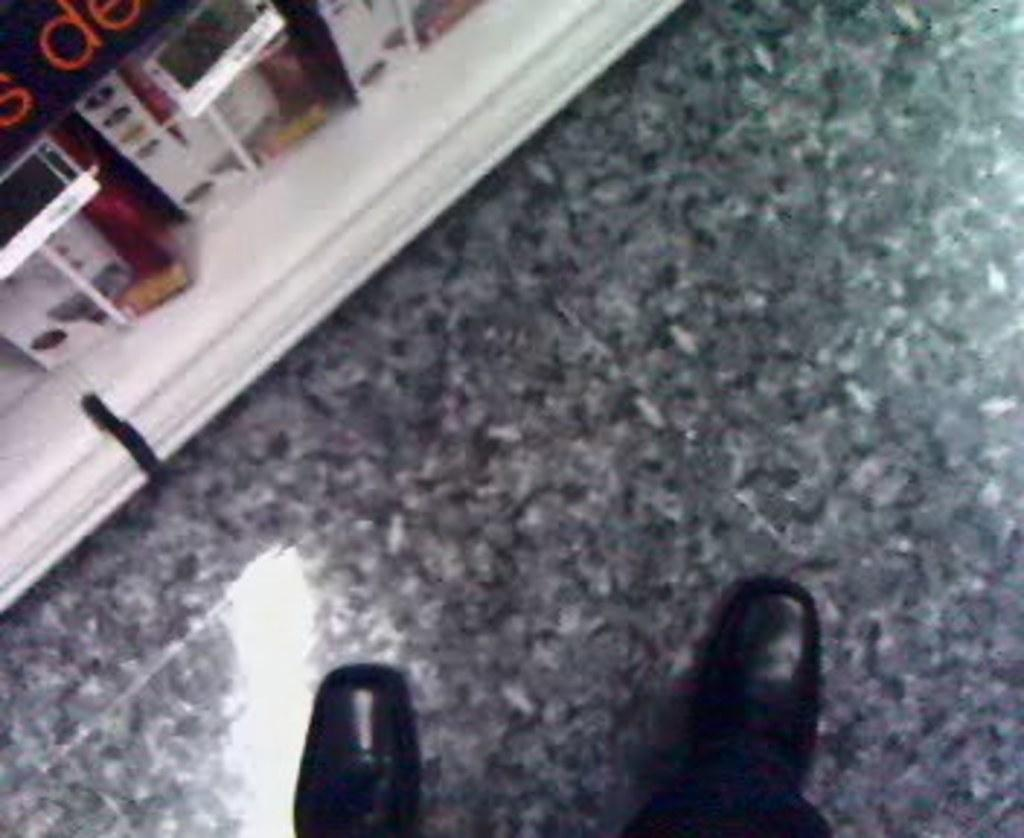What part of a person can be seen in the image? There are legs of a person in the image. What type of footwear is the person wearing? The person is wearing shoes. What surface is the person standing on? The person is standing on the floor. What shape is the cloud in the image? There is no cloud present in the image; it only shows the legs of a person standing on the floor. 